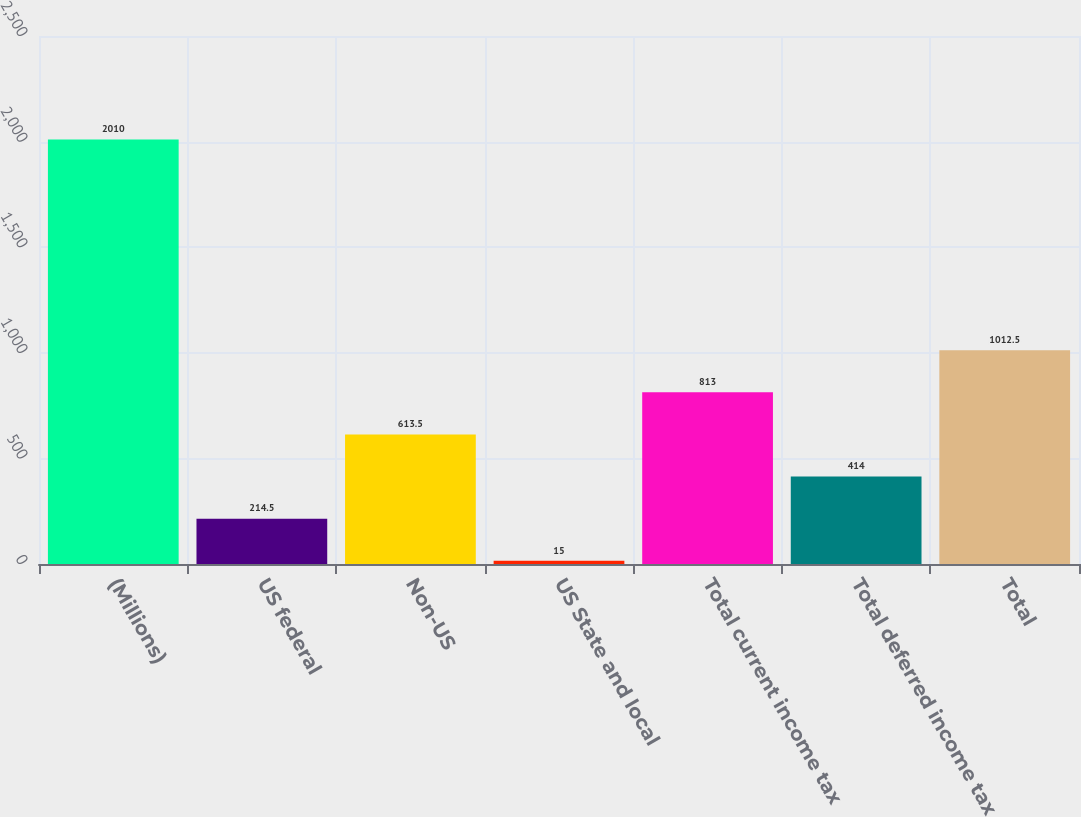<chart> <loc_0><loc_0><loc_500><loc_500><bar_chart><fcel>(Millions)<fcel>US federal<fcel>Non-US<fcel>US State and local<fcel>Total current income tax<fcel>Total deferred income tax<fcel>Total<nl><fcel>2010<fcel>214.5<fcel>613.5<fcel>15<fcel>813<fcel>414<fcel>1012.5<nl></chart> 